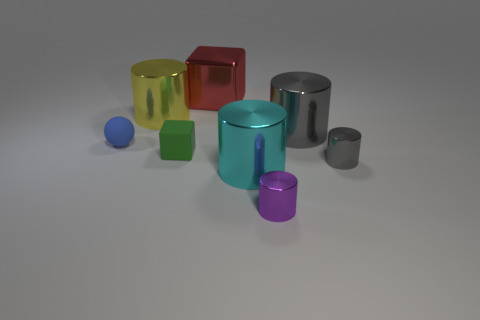The red cube is what size?
Your response must be concise. Large. What shape is the cyan thing?
Offer a very short reply. Cylinder. Are there any other things that are the same shape as the blue matte object?
Offer a terse response. No. Are there fewer large cyan things that are to the left of the tiny matte block than tiny green metal spheres?
Make the answer very short. No. What number of metal things are either purple cylinders or big purple blocks?
Your response must be concise. 1. There is a cube that is made of the same material as the small ball; what color is it?
Offer a terse response. Green. How many blocks are either brown shiny things or big red objects?
Provide a short and direct response. 1. What number of things are either tiny metal cylinders or red shiny things on the left side of the big gray metal cylinder?
Provide a short and direct response. 3. Are any large brown things visible?
Provide a succinct answer. No. What size is the matte thing that is to the left of the large shiny cylinder on the left side of the red metallic block?
Make the answer very short. Small. 